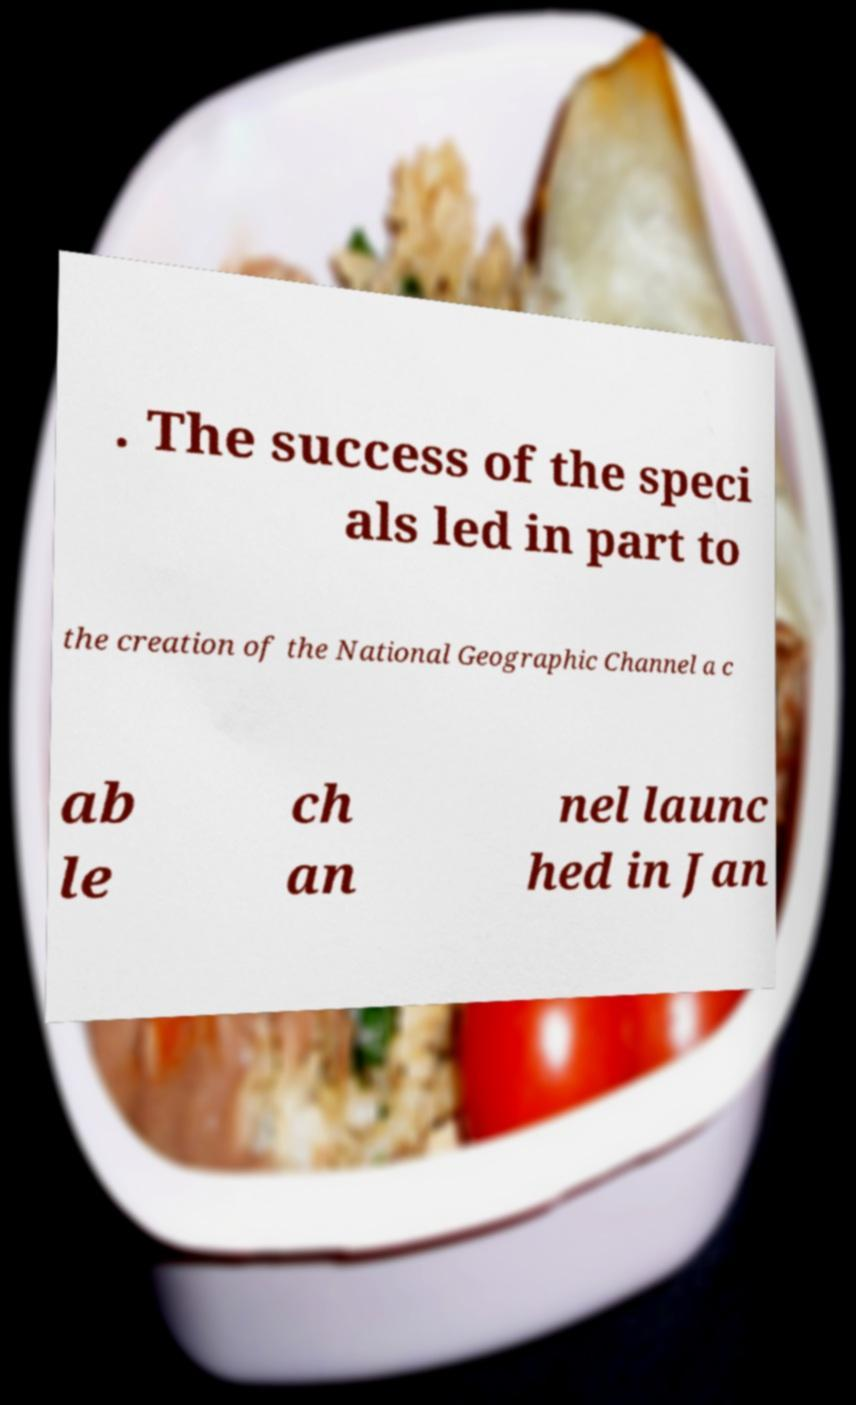Can you accurately transcribe the text from the provided image for me? . The success of the speci als led in part to the creation of the National Geographic Channel a c ab le ch an nel launc hed in Jan 